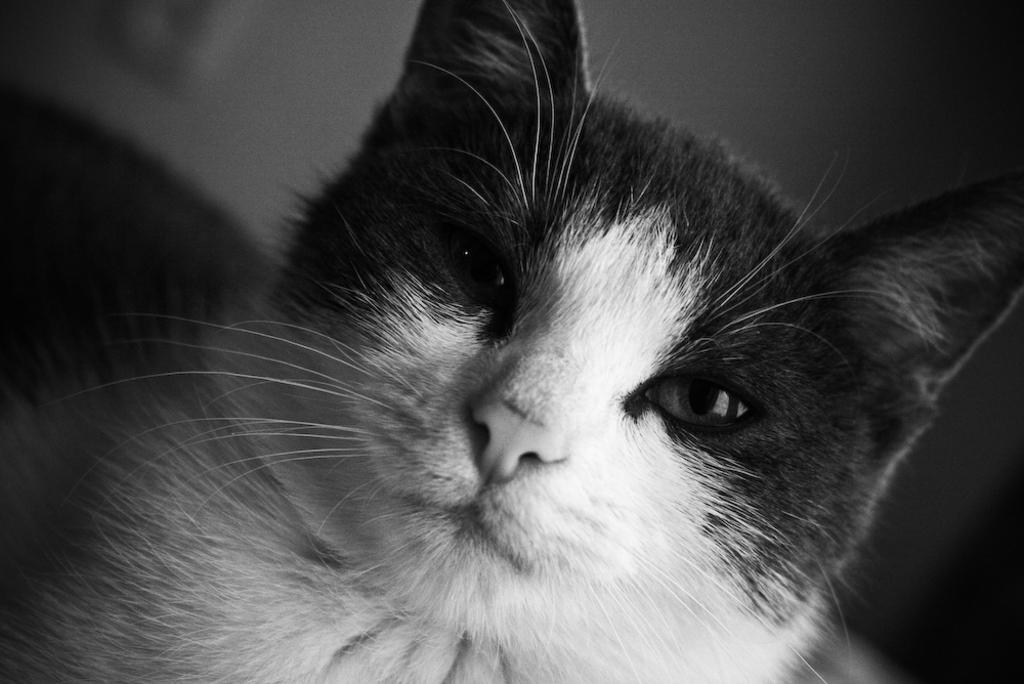What is the color scheme of the image? The image is black and white. What type of animal can be seen in the image? There is a cat in the image. Where is the desk located in the image? There is no desk present in the image. What type of polish is being applied to the cat's teeth in the image? There is no polish or toothbrush visible in the image, and the cat's teeth are not being addressed. 